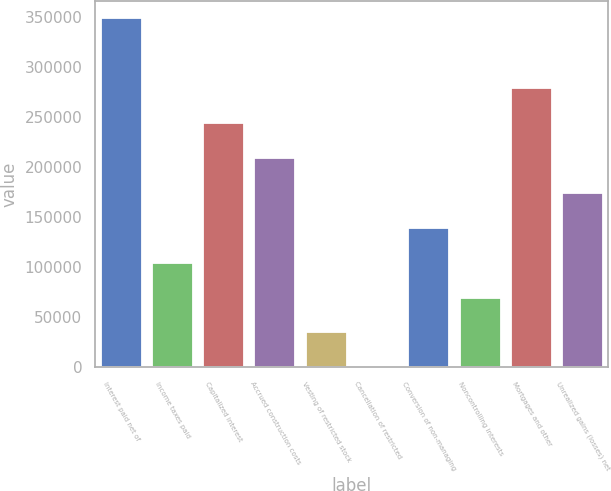Convert chart to OTSL. <chart><loc_0><loc_0><loc_500><loc_500><bar_chart><fcel>Interest paid net of<fcel>Income taxes paid<fcel>Capitalized interest<fcel>Accrued construction costs<fcel>Vesting of restricted stock<fcel>Cancellation of restricted<fcel>Conversion of non-managing<fcel>Noncontrolling interests<fcel>Mortgages and other<fcel>Unrealized gains (losses) net<nl><fcel>348455<fcel>104561<fcel>243929<fcel>209087<fcel>34877<fcel>35<fcel>139403<fcel>69719<fcel>278771<fcel>174245<nl></chart> 